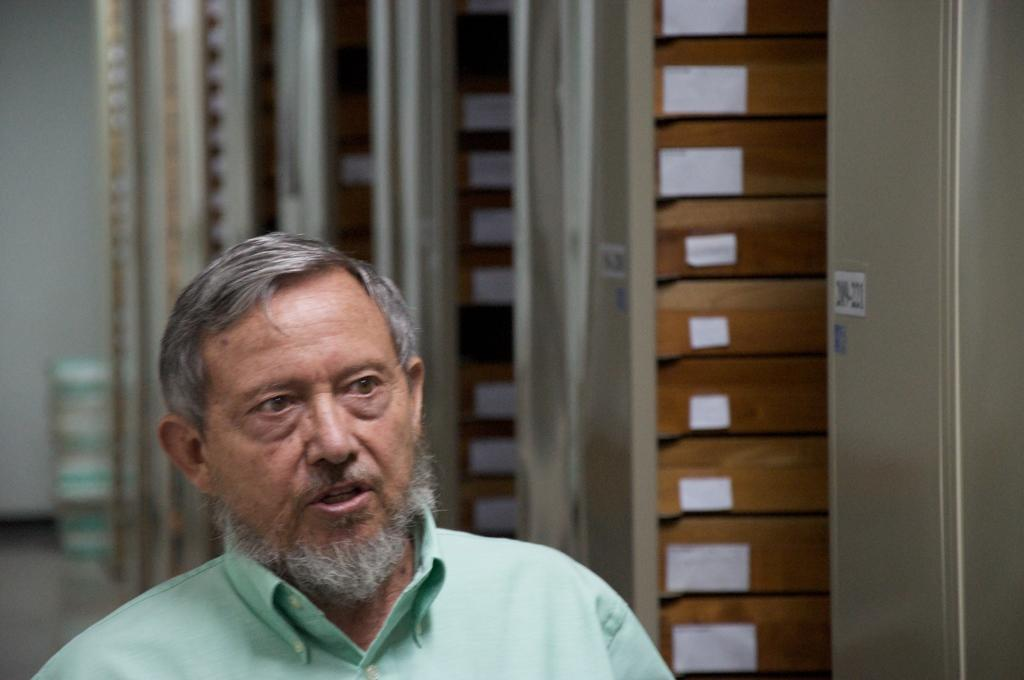Who is the main subject in the image? There is a man in the image. Can you describe the background of the image? The background of the image is blurred. What can be seen in the background of the image? There is a wall and other objects in the background of the image. How many family members are comfortably seated at the airport in the image? There is no information about family members, comfort, or an airport in the image. The image only features a man and a blurred background with a wall and other objects. 